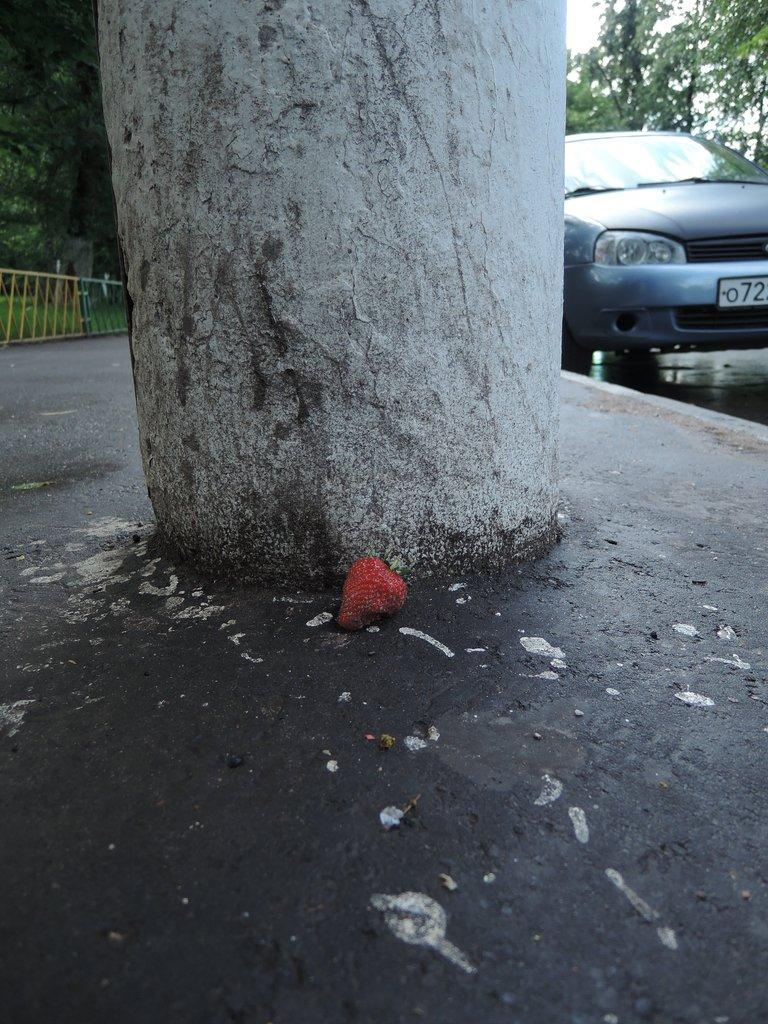What is located in the foreground of the image? There is a strawberry and a trunk in the foreground of the image. What can be seen in the background of the image? There are trees, a vehicle, a boundary, and the sky visible in the background of the image. How many eggs are hidden under the strawberry in the image? There are no eggs present in the image. What type of error can be seen in the image? There is no error present in the image. 